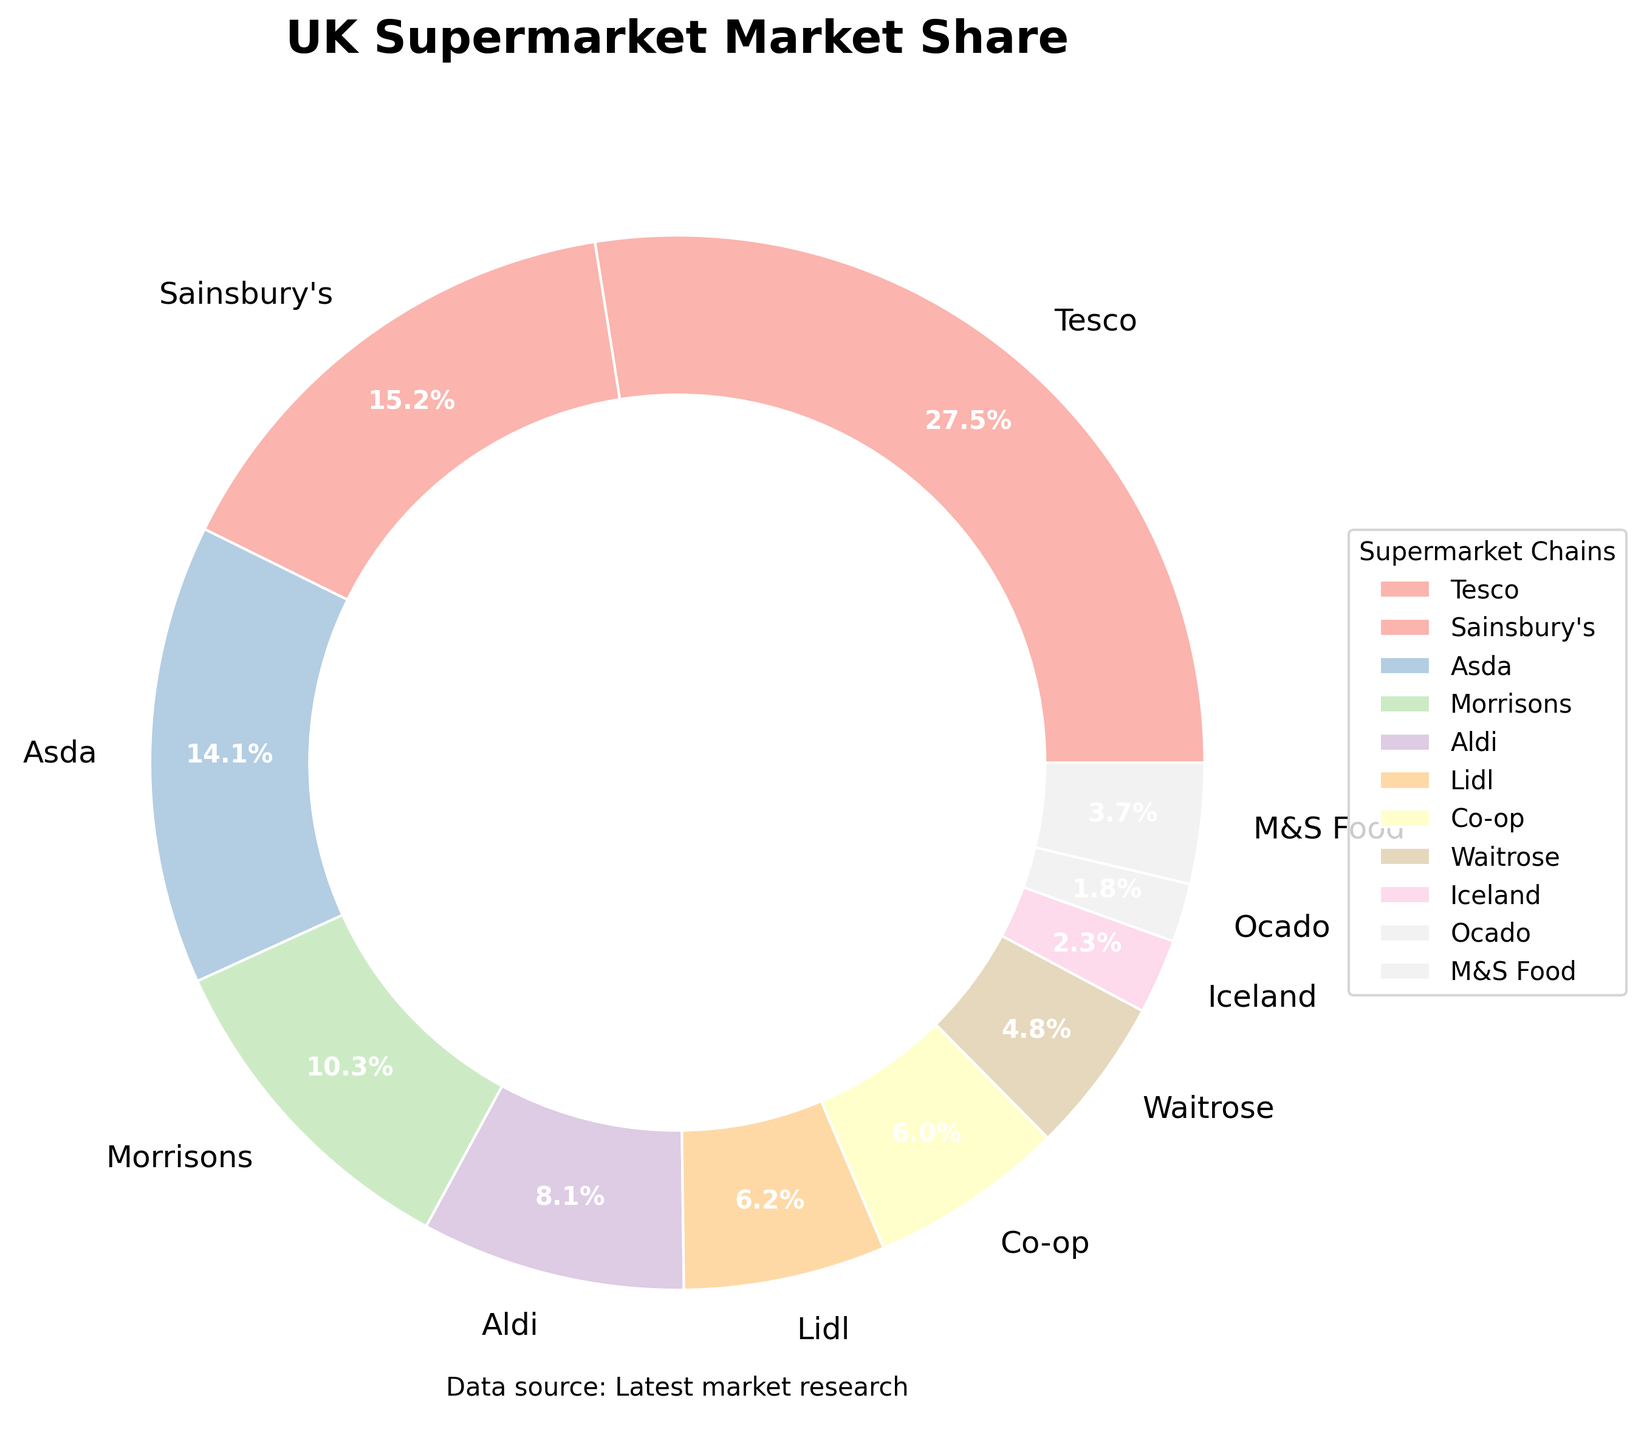Which supermarket chain has the largest market share? The figure shows different wedges for each supermarket chain with their respective market share percentages. The largest wedge is labeled "Tesco" with 27.5%, which is the highest among all.
Answer: Tesco Which two supermarket chains have the smallest market shares? The figure shows all the supermarket chains with their market shares. By looking at the smallest wedges, we can see that Ocado and Iceland have the smallest market shares with 1.8% and 2.3%, respectively.
Answer: Ocado and Iceland What is the combined market share of Tesco and Sainsbury's? The market share for Tesco is 27.5% and for Sainsbury's, it is 15.2%. Adding these together gives the combined market share: 27.5% + 15.2% = 42.7%.
Answer: 42.7% How much larger is Tesco's market share compared to Asda's? Tesco's market share is 27.5% and Asda's is 14.1%. Subtracting Asda's market share from Tesco's gives the difference: 27.5% - 14.1% = 13.4%.
Answer: 13.4% Which supermarket chains have market shares more than 10%? From the figure, Tesco, Sainsbury's, Asda, and Morrisons have market shares greater than 10%, which are 27.5%, 15.2%, 14.1%, and 10.3% respectively.
Answer: Tesco, Sainsbury's, Asda, Morrisons What is the average market share of Aldi and Lidl? Aldi has a market share of 8.1% and Lidl has 6.2%. Their average market share is calculated by: (8.1% + 6.2%) / 2 = 7.15%.
Answer: 7.15% Is M&S Food's market share larger than Co-op's? M&S Food has a market share of 3.7%, while Co-op has a market share of 6.0%. Since 3.7% is less than 6.0%, M&S Food's market share is not larger than Co-op's.
Answer: No What color represents Waitrose in the graph? The figure uses colors from the Pastel1 colormap. Waitrose is a segment in the pie chart marked with a pastel color, specifically in pastel purple.
Answer: Pastel purple If we combine the market shares of Morrisons, Aldi, and Lidl, would it surpass Tesco? Morrisons has a market share of 10.3%, Aldi 8.1%, and Lidl 6.2%. Adding these together gives: 10.3% + 8.1% + 6.2% = 24.6%, which is less than Tesco's 27.5%.
Answer: No 